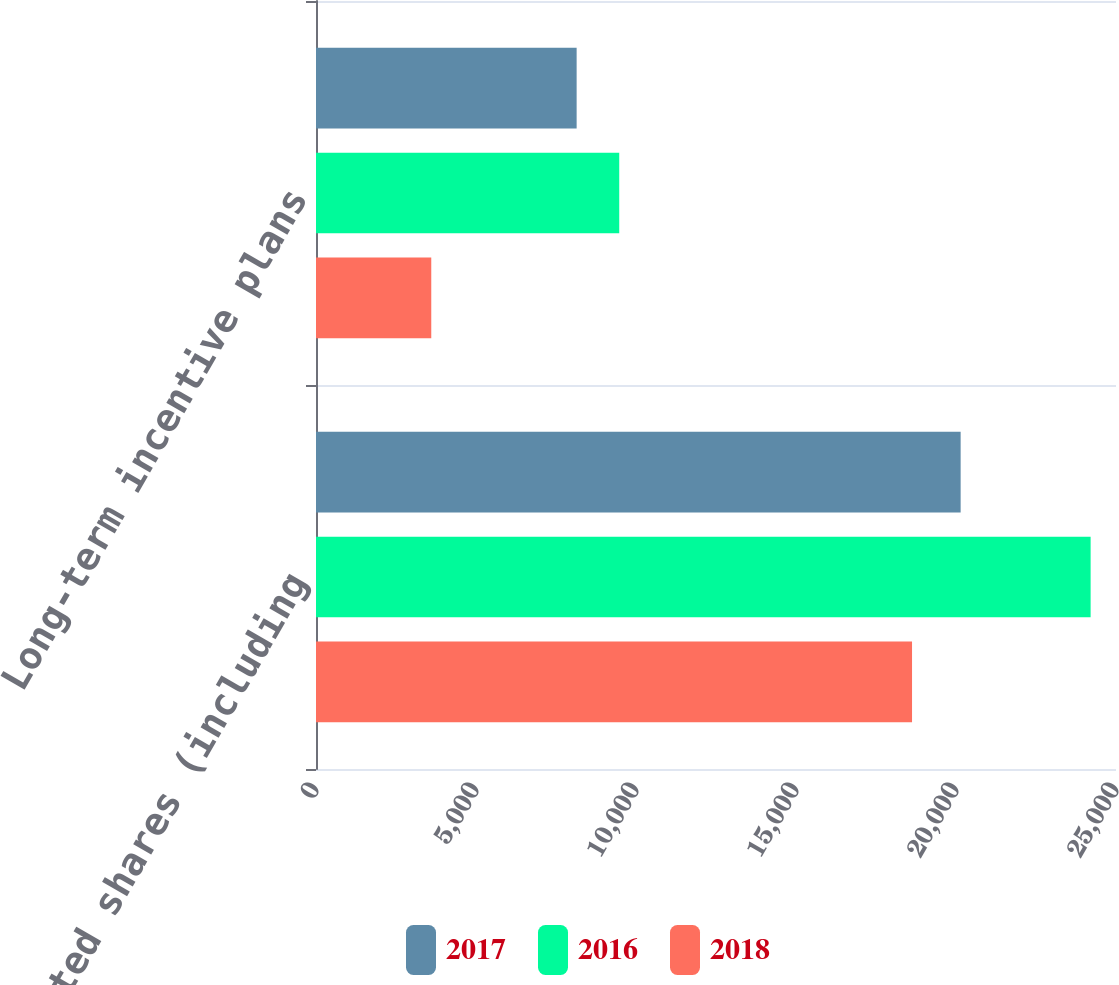Convert chart. <chart><loc_0><loc_0><loc_500><loc_500><stacked_bar_chart><ecel><fcel>Restricted shares (including<fcel>Long-term incentive plans<nl><fcel>2017<fcel>20145<fcel>8145<nl><fcel>2016<fcel>24207<fcel>9476<nl><fcel>2018<fcel>18626<fcel>3602<nl></chart> 